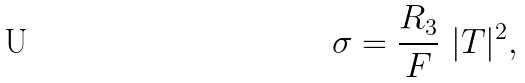<formula> <loc_0><loc_0><loc_500><loc_500>\sigma = \frac { R _ { 3 } } { F } \ | T | ^ { 2 } ,</formula> 